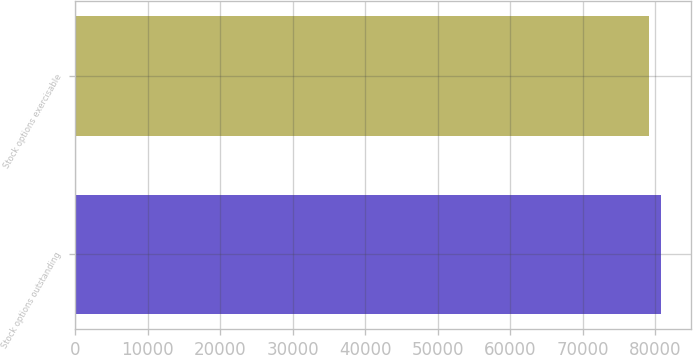Convert chart. <chart><loc_0><loc_0><loc_500><loc_500><bar_chart><fcel>Stock options outstanding<fcel>Stock options exercisable<nl><fcel>80821<fcel>79202<nl></chart> 